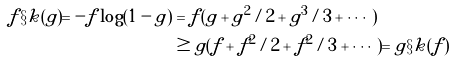<formula> <loc_0><loc_0><loc_500><loc_500>f \S k ( g ) = - f \log ( 1 - g ) & = f ( g + g ^ { 2 } / 2 + g ^ { 3 } / 3 + \cdots ) \\ & \geq g ( f + f ^ { 2 } / 2 + f ^ { 2 } / 3 + \cdots ) = g \S k ( f )</formula> 